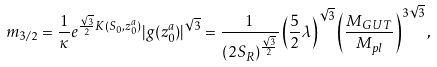Convert formula to latex. <formula><loc_0><loc_0><loc_500><loc_500>m _ { 3 / 2 } = \frac { 1 } { \kappa } e ^ { \frac { \sqrt { 3 } } { 2 } K ( S _ { 0 } , z _ { 0 } ^ { a } ) } | g ( z _ { 0 } ^ { a } ) | ^ { \sqrt { 3 } } = \frac { 1 } { ( 2 S _ { R } ) ^ { \frac { \sqrt { 3 } } { 2 } } } \left ( \frac { 5 } { 2 } \lambda \right ) ^ { \sqrt { 3 } } \left ( \frac { M _ { G U T } } { M _ { p l } } \right ) ^ { 3 \sqrt { 3 } } ,</formula> 